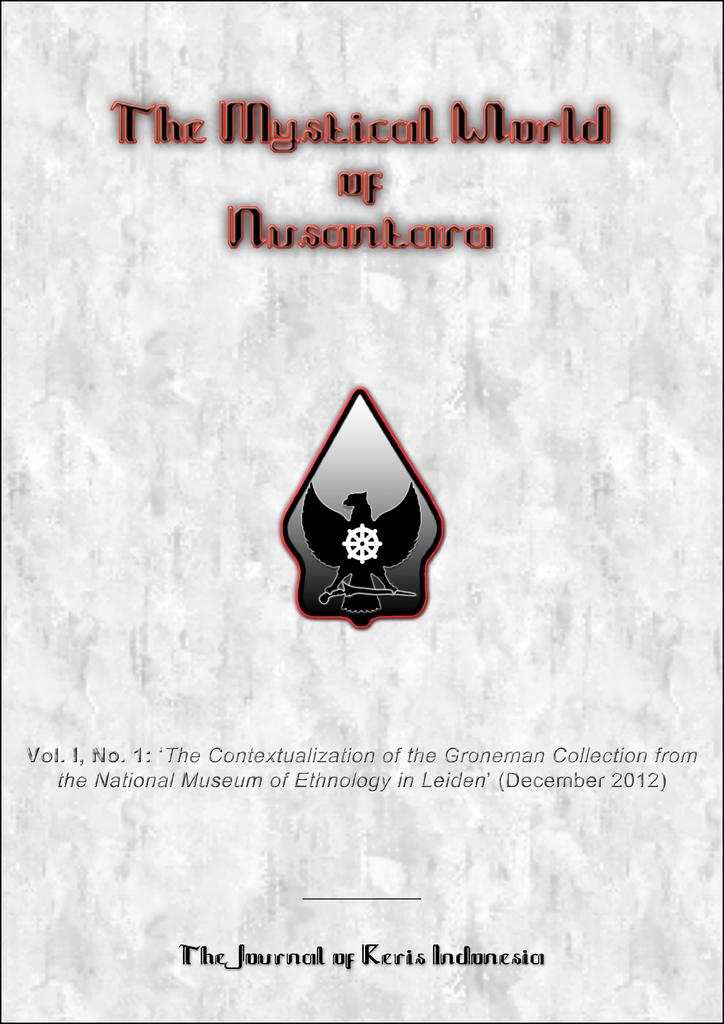What is the name of the book?
Make the answer very short. The mystical world of nusanlara. 